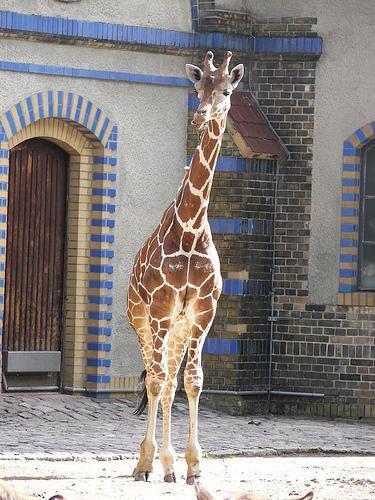How many people are holding a green frisbee?
Give a very brief answer. 0. 